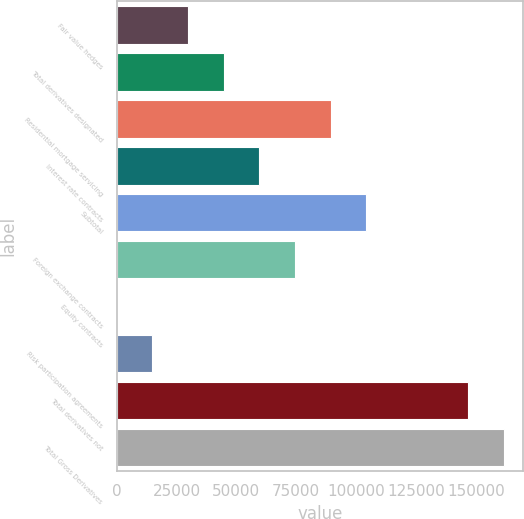Convert chart to OTSL. <chart><loc_0><loc_0><loc_500><loc_500><bar_chart><fcel>Fair value hedges<fcel>Total derivatives designated<fcel>Residential mortgage servicing<fcel>Interest rate contracts<fcel>Subtotal<fcel>Foreign exchange contracts<fcel>Equity contracts<fcel>Risk participation agreements<fcel>Total derivatives not<fcel>Total Gross Derivatives<nl><fcel>29833.6<fcel>44717.4<fcel>89368.8<fcel>59601.2<fcel>104253<fcel>74485<fcel>66<fcel>14949.8<fcel>146688<fcel>161572<nl></chart> 